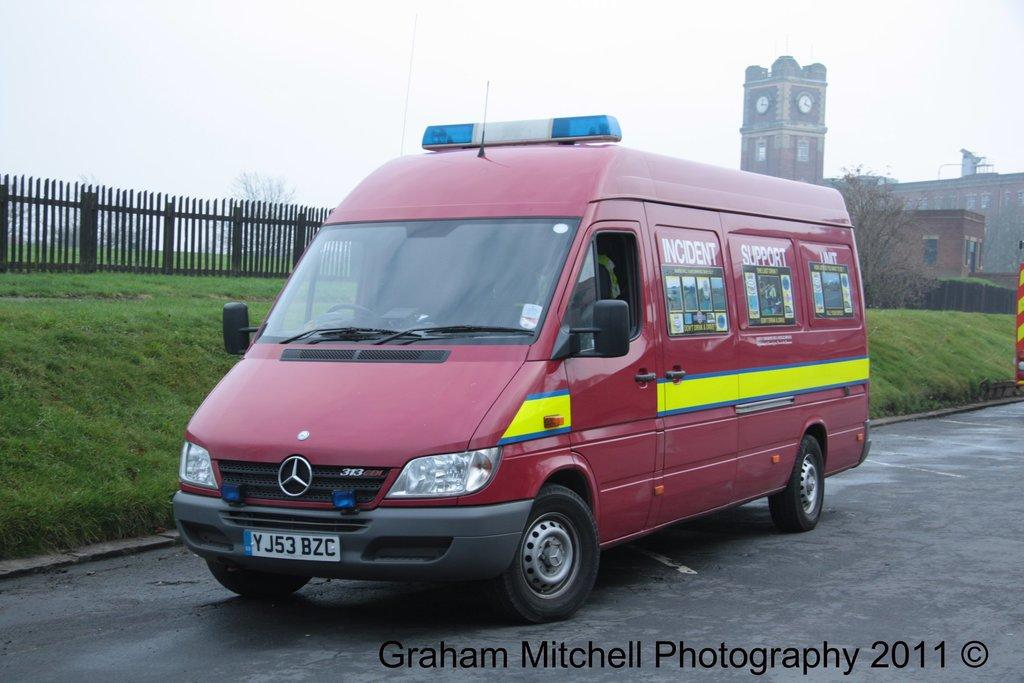Provide a one-sentence caption for the provided image. an Incident Support van is parked along a grassy hill. 